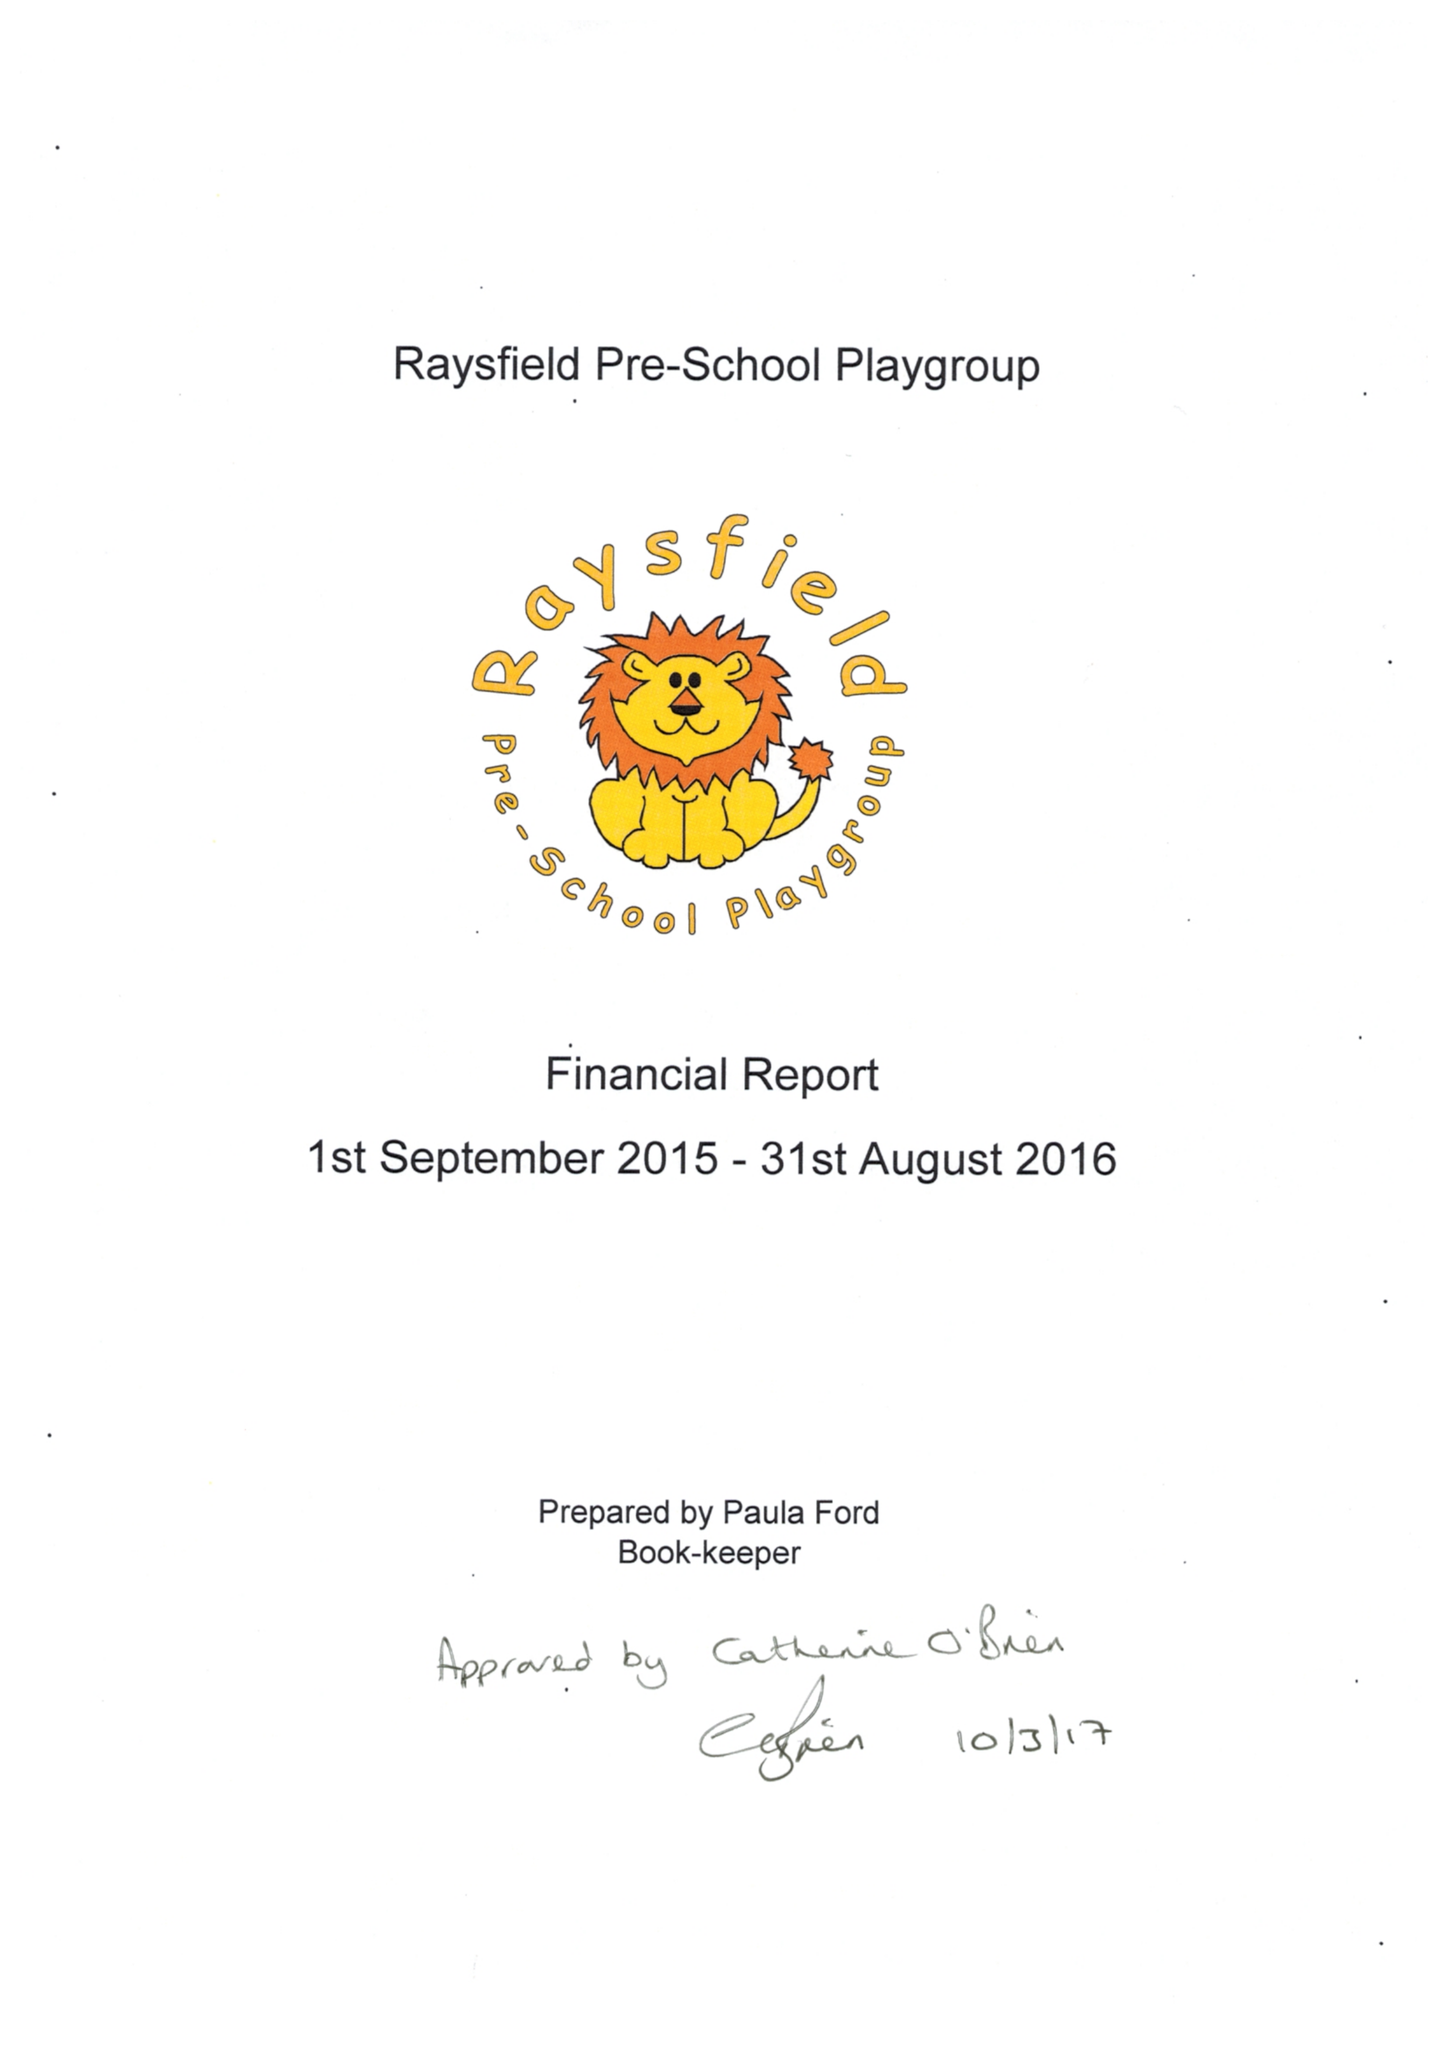What is the value for the charity_number?
Answer the question using a single word or phrase. 1027639 